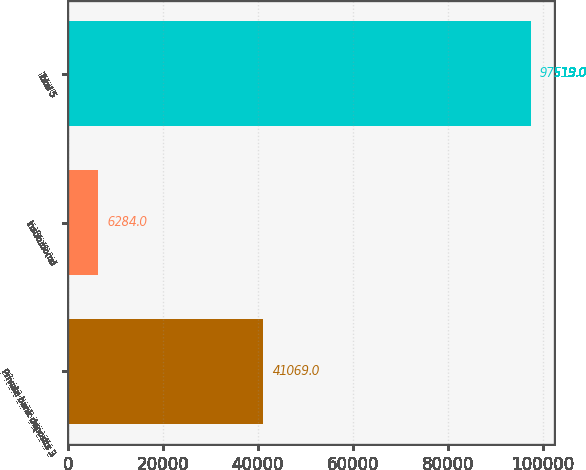Convert chart. <chart><loc_0><loc_0><loc_500><loc_500><bar_chart><fcel>Private bank deposits 3<fcel>Institutional<fcel>Total 5<nl><fcel>41069<fcel>6284<fcel>97519<nl></chart> 